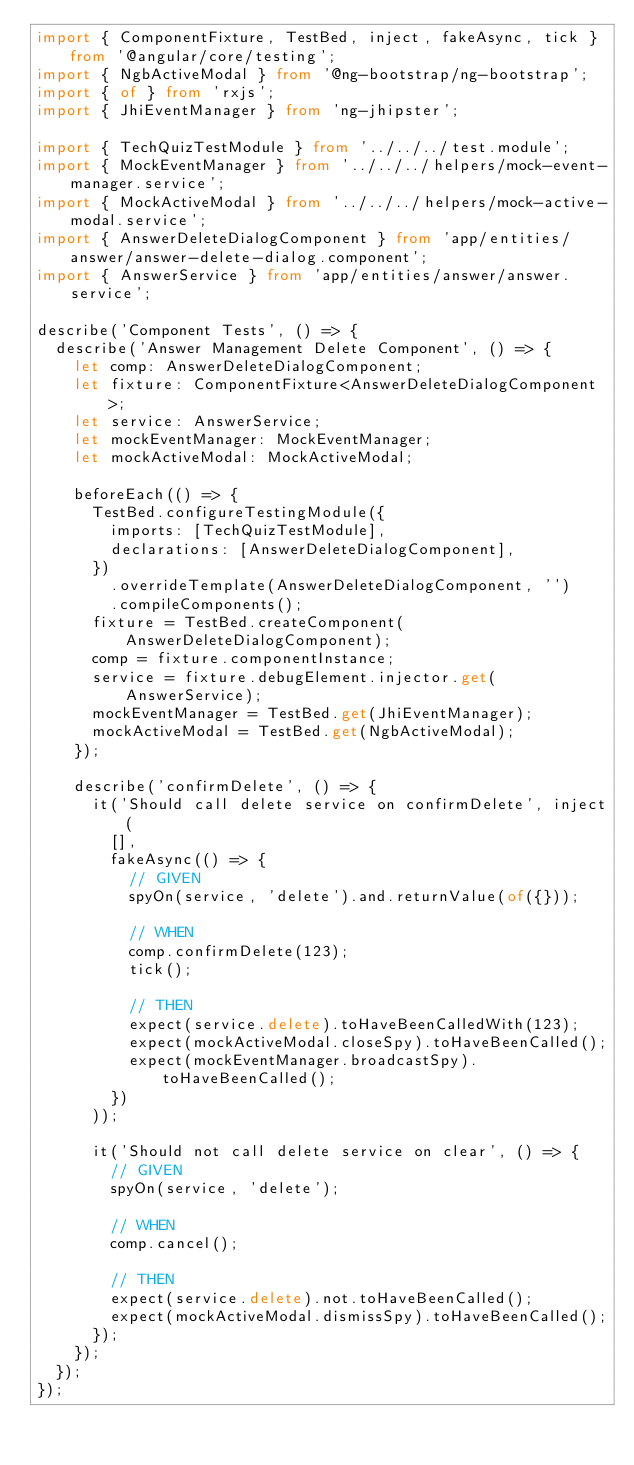Convert code to text. <code><loc_0><loc_0><loc_500><loc_500><_TypeScript_>import { ComponentFixture, TestBed, inject, fakeAsync, tick } from '@angular/core/testing';
import { NgbActiveModal } from '@ng-bootstrap/ng-bootstrap';
import { of } from 'rxjs';
import { JhiEventManager } from 'ng-jhipster';

import { TechQuizTestModule } from '../../../test.module';
import { MockEventManager } from '../../../helpers/mock-event-manager.service';
import { MockActiveModal } from '../../../helpers/mock-active-modal.service';
import { AnswerDeleteDialogComponent } from 'app/entities/answer/answer-delete-dialog.component';
import { AnswerService } from 'app/entities/answer/answer.service';

describe('Component Tests', () => {
  describe('Answer Management Delete Component', () => {
    let comp: AnswerDeleteDialogComponent;
    let fixture: ComponentFixture<AnswerDeleteDialogComponent>;
    let service: AnswerService;
    let mockEventManager: MockEventManager;
    let mockActiveModal: MockActiveModal;

    beforeEach(() => {
      TestBed.configureTestingModule({
        imports: [TechQuizTestModule],
        declarations: [AnswerDeleteDialogComponent],
      })
        .overrideTemplate(AnswerDeleteDialogComponent, '')
        .compileComponents();
      fixture = TestBed.createComponent(AnswerDeleteDialogComponent);
      comp = fixture.componentInstance;
      service = fixture.debugElement.injector.get(AnswerService);
      mockEventManager = TestBed.get(JhiEventManager);
      mockActiveModal = TestBed.get(NgbActiveModal);
    });

    describe('confirmDelete', () => {
      it('Should call delete service on confirmDelete', inject(
        [],
        fakeAsync(() => {
          // GIVEN
          spyOn(service, 'delete').and.returnValue(of({}));

          // WHEN
          comp.confirmDelete(123);
          tick();

          // THEN
          expect(service.delete).toHaveBeenCalledWith(123);
          expect(mockActiveModal.closeSpy).toHaveBeenCalled();
          expect(mockEventManager.broadcastSpy).toHaveBeenCalled();
        })
      ));

      it('Should not call delete service on clear', () => {
        // GIVEN
        spyOn(service, 'delete');

        // WHEN
        comp.cancel();

        // THEN
        expect(service.delete).not.toHaveBeenCalled();
        expect(mockActiveModal.dismissSpy).toHaveBeenCalled();
      });
    });
  });
});
</code> 